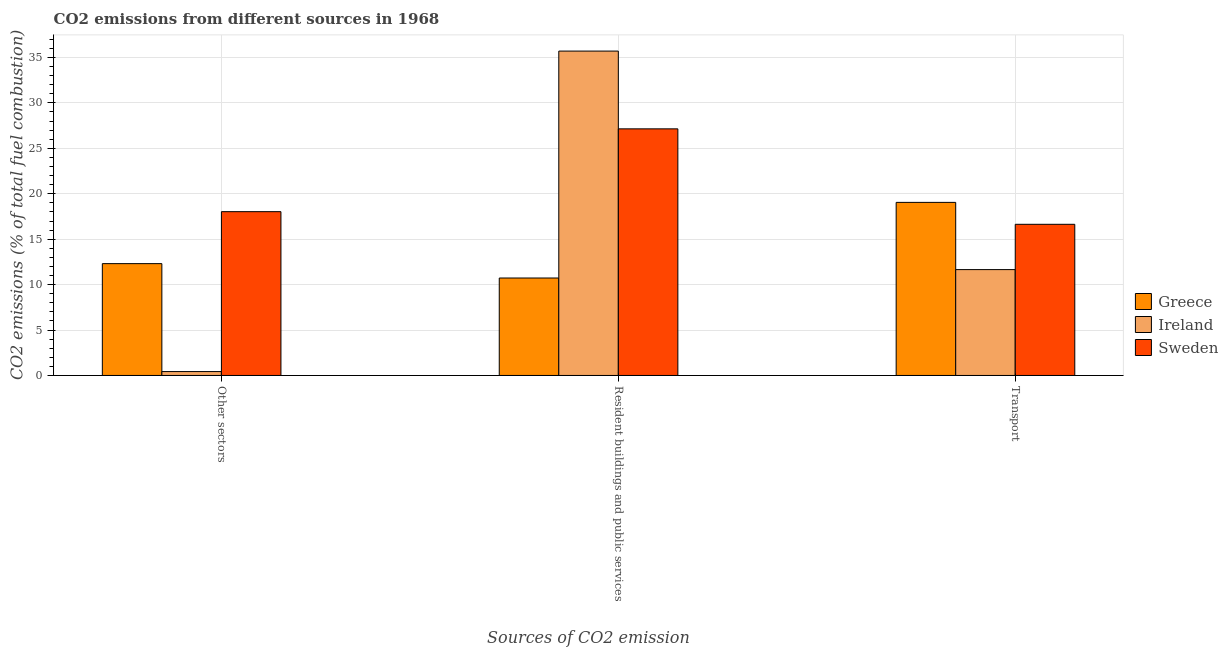Are the number of bars per tick equal to the number of legend labels?
Ensure brevity in your answer.  Yes. How many bars are there on the 2nd tick from the right?
Ensure brevity in your answer.  3. What is the label of the 1st group of bars from the left?
Make the answer very short. Other sectors. What is the percentage of co2 emissions from resident buildings and public services in Ireland?
Ensure brevity in your answer.  35.7. Across all countries, what is the maximum percentage of co2 emissions from transport?
Ensure brevity in your answer.  19.05. Across all countries, what is the minimum percentage of co2 emissions from resident buildings and public services?
Ensure brevity in your answer.  10.73. In which country was the percentage of co2 emissions from resident buildings and public services maximum?
Make the answer very short. Ireland. What is the total percentage of co2 emissions from transport in the graph?
Your answer should be compact. 47.34. What is the difference between the percentage of co2 emissions from resident buildings and public services in Sweden and that in Greece?
Ensure brevity in your answer.  16.42. What is the difference between the percentage of co2 emissions from resident buildings and public services in Greece and the percentage of co2 emissions from other sectors in Sweden?
Your answer should be very brief. -7.3. What is the average percentage of co2 emissions from transport per country?
Offer a terse response. 15.78. What is the difference between the percentage of co2 emissions from transport and percentage of co2 emissions from other sectors in Ireland?
Provide a succinct answer. 11.22. What is the ratio of the percentage of co2 emissions from other sectors in Ireland to that in Greece?
Offer a very short reply. 0.03. Is the percentage of co2 emissions from resident buildings and public services in Greece less than that in Ireland?
Provide a short and direct response. Yes. What is the difference between the highest and the second highest percentage of co2 emissions from other sectors?
Offer a very short reply. 5.72. What is the difference between the highest and the lowest percentage of co2 emissions from transport?
Provide a short and direct response. 7.4. In how many countries, is the percentage of co2 emissions from transport greater than the average percentage of co2 emissions from transport taken over all countries?
Make the answer very short. 2. What does the 3rd bar from the right in Transport represents?
Ensure brevity in your answer.  Greece. Is it the case that in every country, the sum of the percentage of co2 emissions from other sectors and percentage of co2 emissions from resident buildings and public services is greater than the percentage of co2 emissions from transport?
Provide a short and direct response. Yes. Are the values on the major ticks of Y-axis written in scientific E-notation?
Give a very brief answer. No. Does the graph contain any zero values?
Provide a succinct answer. No. Does the graph contain grids?
Offer a very short reply. Yes. Where does the legend appear in the graph?
Give a very brief answer. Center right. What is the title of the graph?
Offer a very short reply. CO2 emissions from different sources in 1968. What is the label or title of the X-axis?
Provide a short and direct response. Sources of CO2 emission. What is the label or title of the Y-axis?
Your answer should be compact. CO2 emissions (% of total fuel combustion). What is the CO2 emissions (% of total fuel combustion) of Greece in Other sectors?
Ensure brevity in your answer.  12.31. What is the CO2 emissions (% of total fuel combustion) in Ireland in Other sectors?
Offer a very short reply. 0.43. What is the CO2 emissions (% of total fuel combustion) in Sweden in Other sectors?
Offer a very short reply. 18.03. What is the CO2 emissions (% of total fuel combustion) in Greece in Resident buildings and public services?
Your response must be concise. 10.73. What is the CO2 emissions (% of total fuel combustion) of Ireland in Resident buildings and public services?
Offer a very short reply. 35.7. What is the CO2 emissions (% of total fuel combustion) of Sweden in Resident buildings and public services?
Make the answer very short. 27.14. What is the CO2 emissions (% of total fuel combustion) in Greece in Transport?
Offer a terse response. 19.05. What is the CO2 emissions (% of total fuel combustion) of Ireland in Transport?
Give a very brief answer. 11.65. What is the CO2 emissions (% of total fuel combustion) in Sweden in Transport?
Ensure brevity in your answer.  16.64. Across all Sources of CO2 emission, what is the maximum CO2 emissions (% of total fuel combustion) in Greece?
Keep it short and to the point. 19.05. Across all Sources of CO2 emission, what is the maximum CO2 emissions (% of total fuel combustion) of Ireland?
Offer a terse response. 35.7. Across all Sources of CO2 emission, what is the maximum CO2 emissions (% of total fuel combustion) of Sweden?
Keep it short and to the point. 27.14. Across all Sources of CO2 emission, what is the minimum CO2 emissions (% of total fuel combustion) of Greece?
Your response must be concise. 10.73. Across all Sources of CO2 emission, what is the minimum CO2 emissions (% of total fuel combustion) of Ireland?
Your answer should be very brief. 0.43. Across all Sources of CO2 emission, what is the minimum CO2 emissions (% of total fuel combustion) in Sweden?
Keep it short and to the point. 16.64. What is the total CO2 emissions (% of total fuel combustion) in Greece in the graph?
Ensure brevity in your answer.  42.09. What is the total CO2 emissions (% of total fuel combustion) in Ireland in the graph?
Ensure brevity in your answer.  47.78. What is the total CO2 emissions (% of total fuel combustion) in Sweden in the graph?
Your answer should be compact. 61.81. What is the difference between the CO2 emissions (% of total fuel combustion) in Greece in Other sectors and that in Resident buildings and public services?
Provide a short and direct response. 1.58. What is the difference between the CO2 emissions (% of total fuel combustion) of Ireland in Other sectors and that in Resident buildings and public services?
Your answer should be compact. -35.28. What is the difference between the CO2 emissions (% of total fuel combustion) of Sweden in Other sectors and that in Resident buildings and public services?
Provide a succinct answer. -9.11. What is the difference between the CO2 emissions (% of total fuel combustion) in Greece in Other sectors and that in Transport?
Provide a succinct answer. -6.74. What is the difference between the CO2 emissions (% of total fuel combustion) in Ireland in Other sectors and that in Transport?
Give a very brief answer. -11.22. What is the difference between the CO2 emissions (% of total fuel combustion) in Sweden in Other sectors and that in Transport?
Your answer should be very brief. 1.39. What is the difference between the CO2 emissions (% of total fuel combustion) in Greece in Resident buildings and public services and that in Transport?
Ensure brevity in your answer.  -8.32. What is the difference between the CO2 emissions (% of total fuel combustion) of Ireland in Resident buildings and public services and that in Transport?
Provide a succinct answer. 24.05. What is the difference between the CO2 emissions (% of total fuel combustion) of Sweden in Resident buildings and public services and that in Transport?
Offer a terse response. 10.51. What is the difference between the CO2 emissions (% of total fuel combustion) in Greece in Other sectors and the CO2 emissions (% of total fuel combustion) in Ireland in Resident buildings and public services?
Your response must be concise. -23.39. What is the difference between the CO2 emissions (% of total fuel combustion) in Greece in Other sectors and the CO2 emissions (% of total fuel combustion) in Sweden in Resident buildings and public services?
Make the answer very short. -14.83. What is the difference between the CO2 emissions (% of total fuel combustion) of Ireland in Other sectors and the CO2 emissions (% of total fuel combustion) of Sweden in Resident buildings and public services?
Your answer should be compact. -26.72. What is the difference between the CO2 emissions (% of total fuel combustion) of Greece in Other sectors and the CO2 emissions (% of total fuel combustion) of Ireland in Transport?
Your answer should be very brief. 0.66. What is the difference between the CO2 emissions (% of total fuel combustion) in Greece in Other sectors and the CO2 emissions (% of total fuel combustion) in Sweden in Transport?
Make the answer very short. -4.33. What is the difference between the CO2 emissions (% of total fuel combustion) in Ireland in Other sectors and the CO2 emissions (% of total fuel combustion) in Sweden in Transport?
Give a very brief answer. -16.21. What is the difference between the CO2 emissions (% of total fuel combustion) in Greece in Resident buildings and public services and the CO2 emissions (% of total fuel combustion) in Ireland in Transport?
Keep it short and to the point. -0.92. What is the difference between the CO2 emissions (% of total fuel combustion) of Greece in Resident buildings and public services and the CO2 emissions (% of total fuel combustion) of Sweden in Transport?
Provide a succinct answer. -5.91. What is the difference between the CO2 emissions (% of total fuel combustion) in Ireland in Resident buildings and public services and the CO2 emissions (% of total fuel combustion) in Sweden in Transport?
Offer a very short reply. 19.06. What is the average CO2 emissions (% of total fuel combustion) of Greece per Sources of CO2 emission?
Make the answer very short. 14.03. What is the average CO2 emissions (% of total fuel combustion) of Ireland per Sources of CO2 emission?
Ensure brevity in your answer.  15.93. What is the average CO2 emissions (% of total fuel combustion) of Sweden per Sources of CO2 emission?
Offer a terse response. 20.6. What is the difference between the CO2 emissions (% of total fuel combustion) of Greece and CO2 emissions (% of total fuel combustion) of Ireland in Other sectors?
Keep it short and to the point. 11.88. What is the difference between the CO2 emissions (% of total fuel combustion) in Greece and CO2 emissions (% of total fuel combustion) in Sweden in Other sectors?
Offer a very short reply. -5.72. What is the difference between the CO2 emissions (% of total fuel combustion) in Ireland and CO2 emissions (% of total fuel combustion) in Sweden in Other sectors?
Your response must be concise. -17.6. What is the difference between the CO2 emissions (% of total fuel combustion) in Greece and CO2 emissions (% of total fuel combustion) in Ireland in Resident buildings and public services?
Your response must be concise. -24.98. What is the difference between the CO2 emissions (% of total fuel combustion) of Greece and CO2 emissions (% of total fuel combustion) of Sweden in Resident buildings and public services?
Provide a short and direct response. -16.42. What is the difference between the CO2 emissions (% of total fuel combustion) of Ireland and CO2 emissions (% of total fuel combustion) of Sweden in Resident buildings and public services?
Keep it short and to the point. 8.56. What is the difference between the CO2 emissions (% of total fuel combustion) of Greece and CO2 emissions (% of total fuel combustion) of Ireland in Transport?
Give a very brief answer. 7.4. What is the difference between the CO2 emissions (% of total fuel combustion) in Greece and CO2 emissions (% of total fuel combustion) in Sweden in Transport?
Offer a very short reply. 2.41. What is the difference between the CO2 emissions (% of total fuel combustion) in Ireland and CO2 emissions (% of total fuel combustion) in Sweden in Transport?
Offer a very short reply. -4.99. What is the ratio of the CO2 emissions (% of total fuel combustion) in Greece in Other sectors to that in Resident buildings and public services?
Offer a terse response. 1.15. What is the ratio of the CO2 emissions (% of total fuel combustion) in Ireland in Other sectors to that in Resident buildings and public services?
Keep it short and to the point. 0.01. What is the ratio of the CO2 emissions (% of total fuel combustion) of Sweden in Other sectors to that in Resident buildings and public services?
Provide a short and direct response. 0.66. What is the ratio of the CO2 emissions (% of total fuel combustion) in Greece in Other sectors to that in Transport?
Keep it short and to the point. 0.65. What is the ratio of the CO2 emissions (% of total fuel combustion) in Ireland in Other sectors to that in Transport?
Your answer should be very brief. 0.04. What is the ratio of the CO2 emissions (% of total fuel combustion) in Sweden in Other sectors to that in Transport?
Make the answer very short. 1.08. What is the ratio of the CO2 emissions (% of total fuel combustion) in Greece in Resident buildings and public services to that in Transport?
Your response must be concise. 0.56. What is the ratio of the CO2 emissions (% of total fuel combustion) in Ireland in Resident buildings and public services to that in Transport?
Make the answer very short. 3.06. What is the ratio of the CO2 emissions (% of total fuel combustion) in Sweden in Resident buildings and public services to that in Transport?
Ensure brevity in your answer.  1.63. What is the difference between the highest and the second highest CO2 emissions (% of total fuel combustion) in Greece?
Ensure brevity in your answer.  6.74. What is the difference between the highest and the second highest CO2 emissions (% of total fuel combustion) of Ireland?
Offer a very short reply. 24.05. What is the difference between the highest and the second highest CO2 emissions (% of total fuel combustion) of Sweden?
Give a very brief answer. 9.11. What is the difference between the highest and the lowest CO2 emissions (% of total fuel combustion) of Greece?
Provide a short and direct response. 8.32. What is the difference between the highest and the lowest CO2 emissions (% of total fuel combustion) of Ireland?
Provide a succinct answer. 35.28. What is the difference between the highest and the lowest CO2 emissions (% of total fuel combustion) of Sweden?
Your answer should be compact. 10.51. 